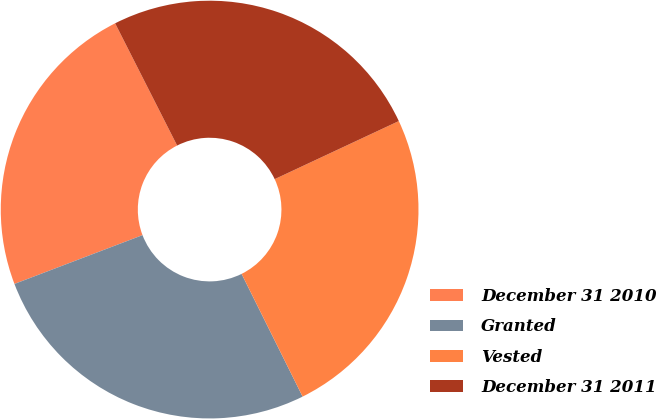Convert chart. <chart><loc_0><loc_0><loc_500><loc_500><pie_chart><fcel>December 31 2010<fcel>Granted<fcel>Vested<fcel>December 31 2011<nl><fcel>23.32%<fcel>26.55%<fcel>24.62%<fcel>25.51%<nl></chart> 